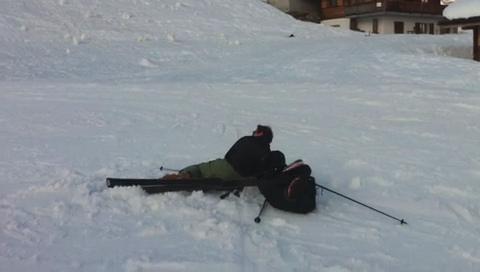What happened to this person?
Select the correct answer and articulate reasoning with the following format: 'Answer: answer
Rationale: rationale.'
Options: Slept, ate food, strapped, fell down. Answer: fell down.
Rationale: They lost their balance while skiing. 